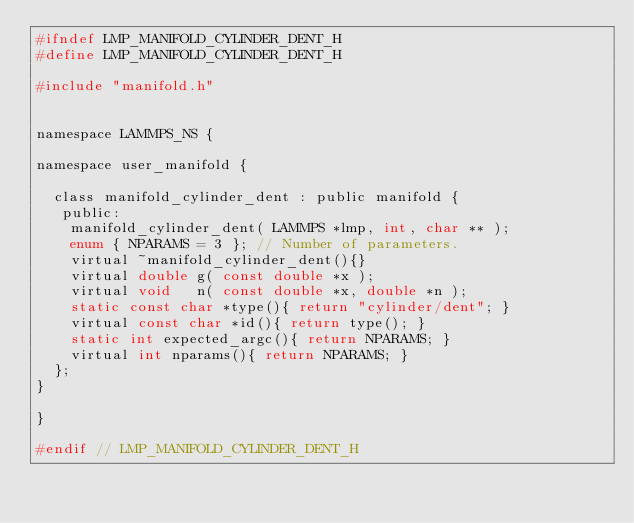<code> <loc_0><loc_0><loc_500><loc_500><_C_>#ifndef LMP_MANIFOLD_CYLINDER_DENT_H
#define LMP_MANIFOLD_CYLINDER_DENT_H

#include "manifold.h"


namespace LAMMPS_NS {

namespace user_manifold {

  class manifold_cylinder_dent : public manifold {
   public:
    manifold_cylinder_dent( LAMMPS *lmp, int, char ** );
    enum { NPARAMS = 3 }; // Number of parameters.
    virtual ~manifold_cylinder_dent(){}
    virtual double g( const double *x );
    virtual void   n( const double *x, double *n );
    static const char *type(){ return "cylinder/dent"; }
    virtual const char *id(){ return type(); }
    static int expected_argc(){ return NPARAMS; }
    virtual int nparams(){ return NPARAMS; }
  };
}

}

#endif // LMP_MANIFOLD_CYLINDER_DENT_H
</code> 